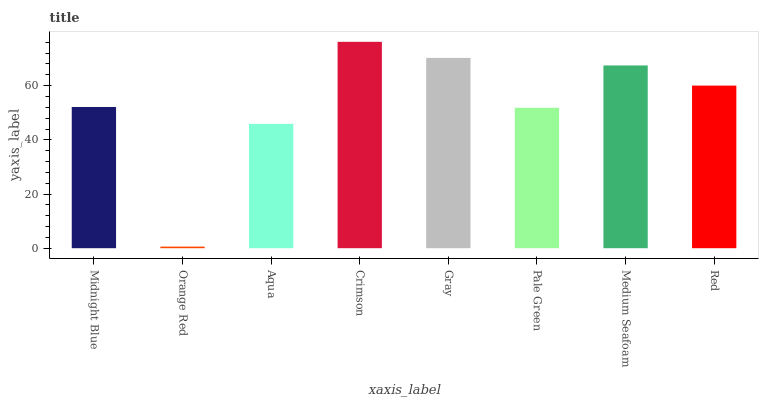Is Orange Red the minimum?
Answer yes or no. Yes. Is Crimson the maximum?
Answer yes or no. Yes. Is Aqua the minimum?
Answer yes or no. No. Is Aqua the maximum?
Answer yes or no. No. Is Aqua greater than Orange Red?
Answer yes or no. Yes. Is Orange Red less than Aqua?
Answer yes or no. Yes. Is Orange Red greater than Aqua?
Answer yes or no. No. Is Aqua less than Orange Red?
Answer yes or no. No. Is Red the high median?
Answer yes or no. Yes. Is Midnight Blue the low median?
Answer yes or no. Yes. Is Orange Red the high median?
Answer yes or no. No. Is Medium Seafoam the low median?
Answer yes or no. No. 